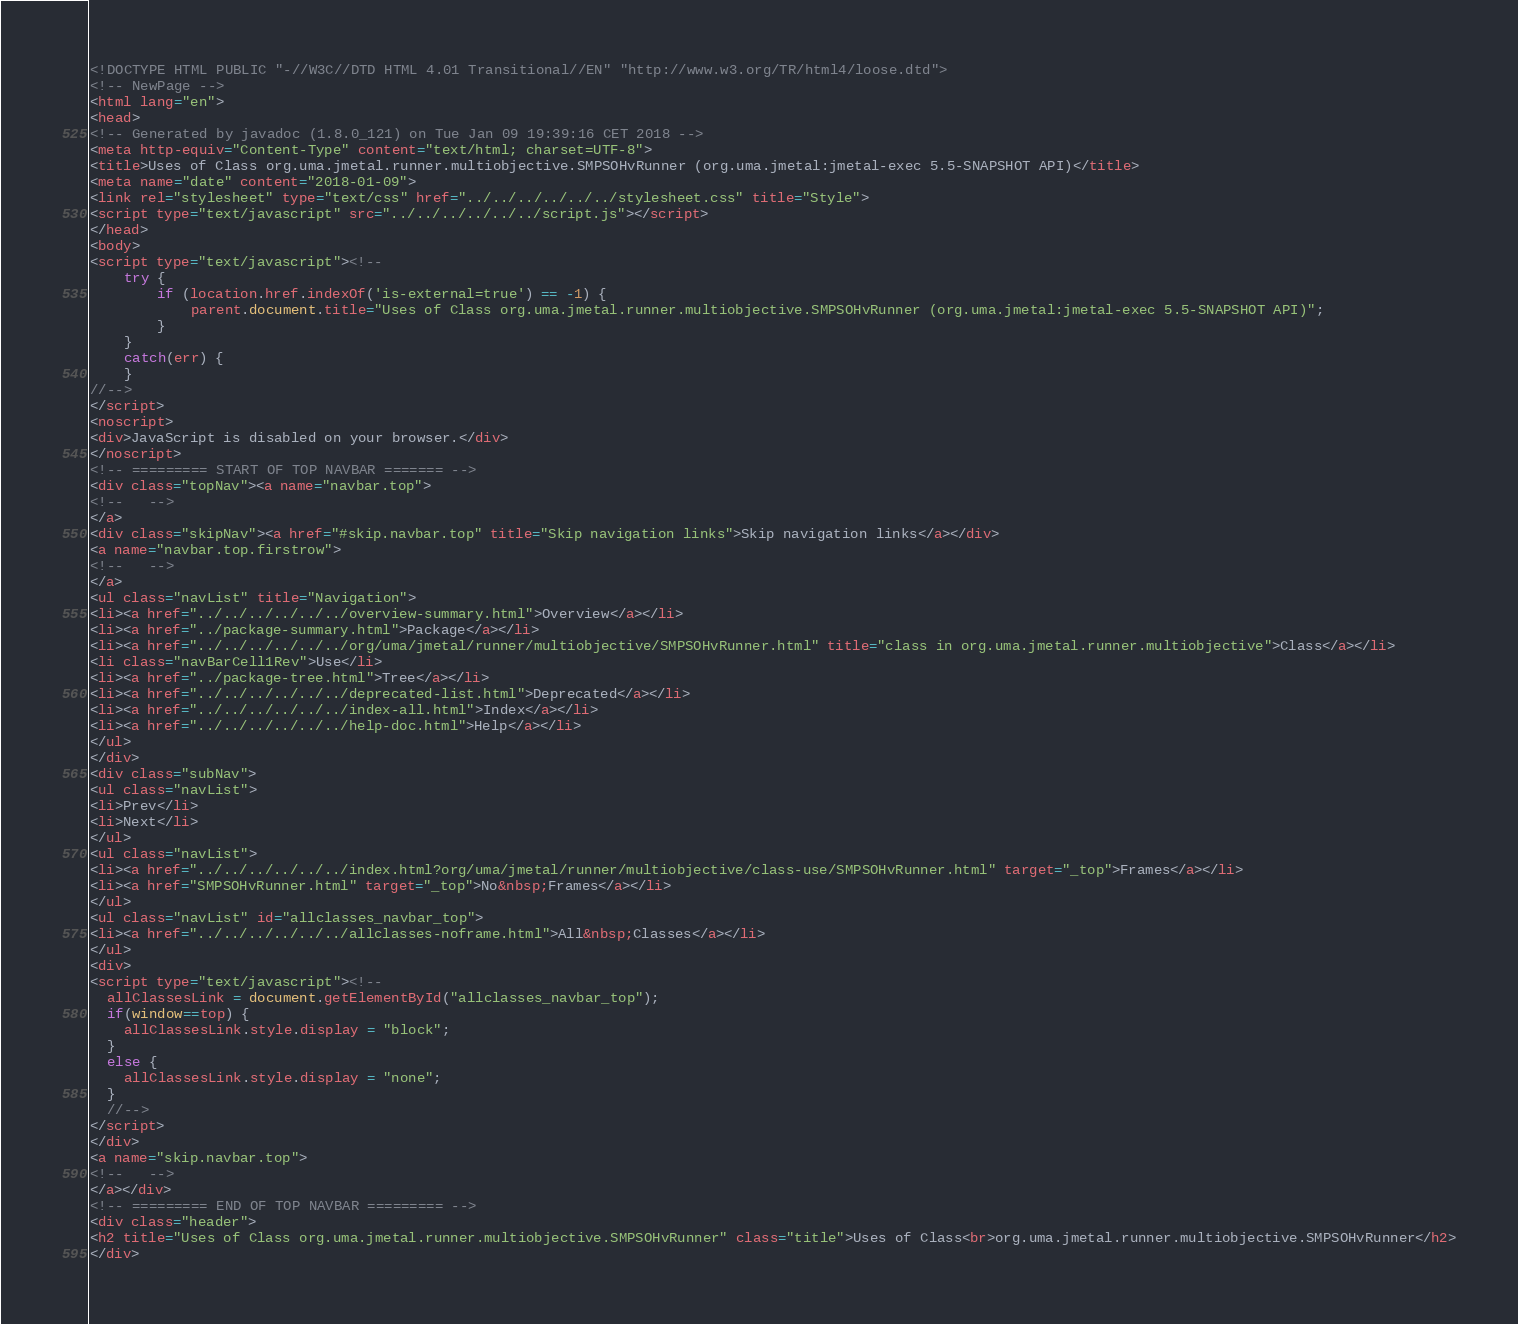Convert code to text. <code><loc_0><loc_0><loc_500><loc_500><_HTML_><!DOCTYPE HTML PUBLIC "-//W3C//DTD HTML 4.01 Transitional//EN" "http://www.w3.org/TR/html4/loose.dtd">
<!-- NewPage -->
<html lang="en">
<head>
<!-- Generated by javadoc (1.8.0_121) on Tue Jan 09 19:39:16 CET 2018 -->
<meta http-equiv="Content-Type" content="text/html; charset=UTF-8">
<title>Uses of Class org.uma.jmetal.runner.multiobjective.SMPSOHvRunner (org.uma.jmetal:jmetal-exec 5.5-SNAPSHOT API)</title>
<meta name="date" content="2018-01-09">
<link rel="stylesheet" type="text/css" href="../../../../../../stylesheet.css" title="Style">
<script type="text/javascript" src="../../../../../../script.js"></script>
</head>
<body>
<script type="text/javascript"><!--
    try {
        if (location.href.indexOf('is-external=true') == -1) {
            parent.document.title="Uses of Class org.uma.jmetal.runner.multiobjective.SMPSOHvRunner (org.uma.jmetal:jmetal-exec 5.5-SNAPSHOT API)";
        }
    }
    catch(err) {
    }
//-->
</script>
<noscript>
<div>JavaScript is disabled on your browser.</div>
</noscript>
<!-- ========= START OF TOP NAVBAR ======= -->
<div class="topNav"><a name="navbar.top">
<!--   -->
</a>
<div class="skipNav"><a href="#skip.navbar.top" title="Skip navigation links">Skip navigation links</a></div>
<a name="navbar.top.firstrow">
<!--   -->
</a>
<ul class="navList" title="Navigation">
<li><a href="../../../../../../overview-summary.html">Overview</a></li>
<li><a href="../package-summary.html">Package</a></li>
<li><a href="../../../../../../org/uma/jmetal/runner/multiobjective/SMPSOHvRunner.html" title="class in org.uma.jmetal.runner.multiobjective">Class</a></li>
<li class="navBarCell1Rev">Use</li>
<li><a href="../package-tree.html">Tree</a></li>
<li><a href="../../../../../../deprecated-list.html">Deprecated</a></li>
<li><a href="../../../../../../index-all.html">Index</a></li>
<li><a href="../../../../../../help-doc.html">Help</a></li>
</ul>
</div>
<div class="subNav">
<ul class="navList">
<li>Prev</li>
<li>Next</li>
</ul>
<ul class="navList">
<li><a href="../../../../../../index.html?org/uma/jmetal/runner/multiobjective/class-use/SMPSOHvRunner.html" target="_top">Frames</a></li>
<li><a href="SMPSOHvRunner.html" target="_top">No&nbsp;Frames</a></li>
</ul>
<ul class="navList" id="allclasses_navbar_top">
<li><a href="../../../../../../allclasses-noframe.html">All&nbsp;Classes</a></li>
</ul>
<div>
<script type="text/javascript"><!--
  allClassesLink = document.getElementById("allclasses_navbar_top");
  if(window==top) {
    allClassesLink.style.display = "block";
  }
  else {
    allClassesLink.style.display = "none";
  }
  //-->
</script>
</div>
<a name="skip.navbar.top">
<!--   -->
</a></div>
<!-- ========= END OF TOP NAVBAR ========= -->
<div class="header">
<h2 title="Uses of Class org.uma.jmetal.runner.multiobjective.SMPSOHvRunner" class="title">Uses of Class<br>org.uma.jmetal.runner.multiobjective.SMPSOHvRunner</h2>
</div></code> 